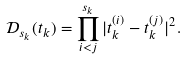Convert formula to latex. <formula><loc_0><loc_0><loc_500><loc_500>\mathcal { D } _ { s _ { k } } ( t _ { k } ) = \prod _ { i < j } ^ { s _ { k } } | t _ { k } ^ { ( i ) } - t _ { k } ^ { ( j ) } | ^ { 2 } .</formula> 